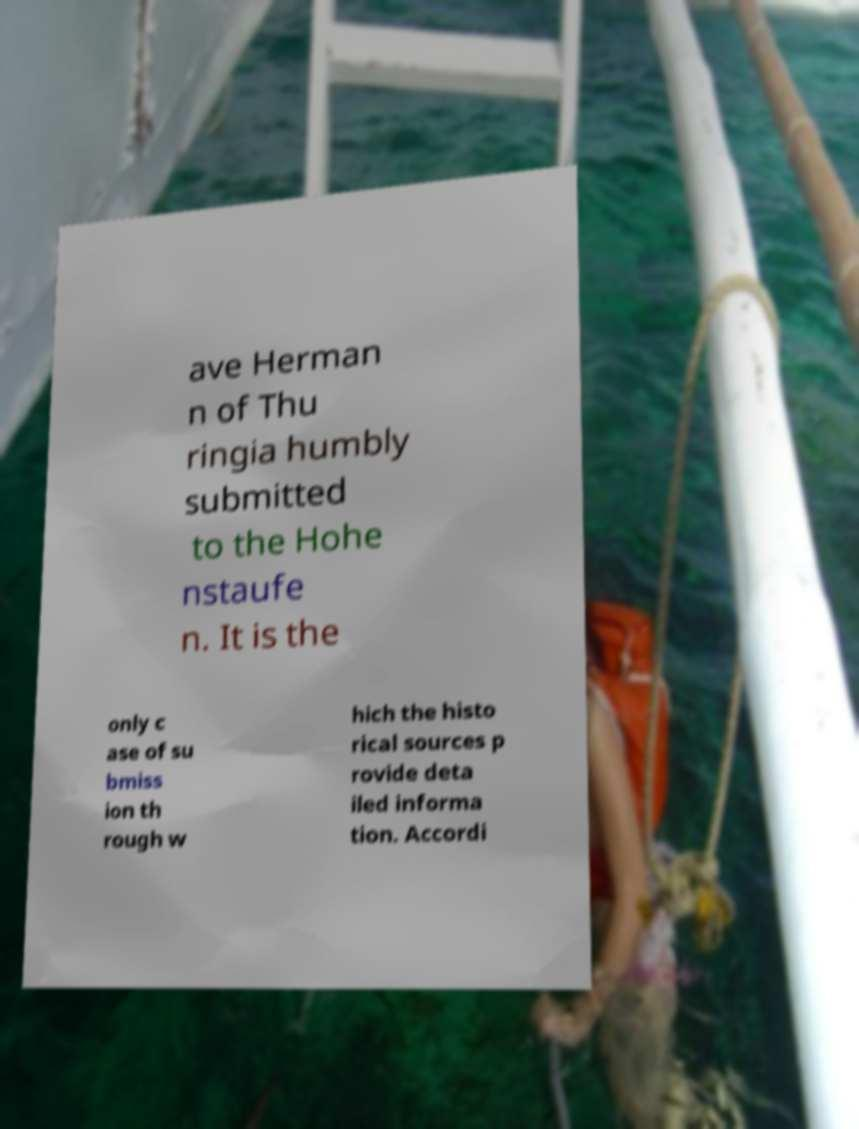There's text embedded in this image that I need extracted. Can you transcribe it verbatim? ave Herman n of Thu ringia humbly submitted to the Hohe nstaufe n. It is the only c ase of su bmiss ion th rough w hich the histo rical sources p rovide deta iled informa tion. Accordi 